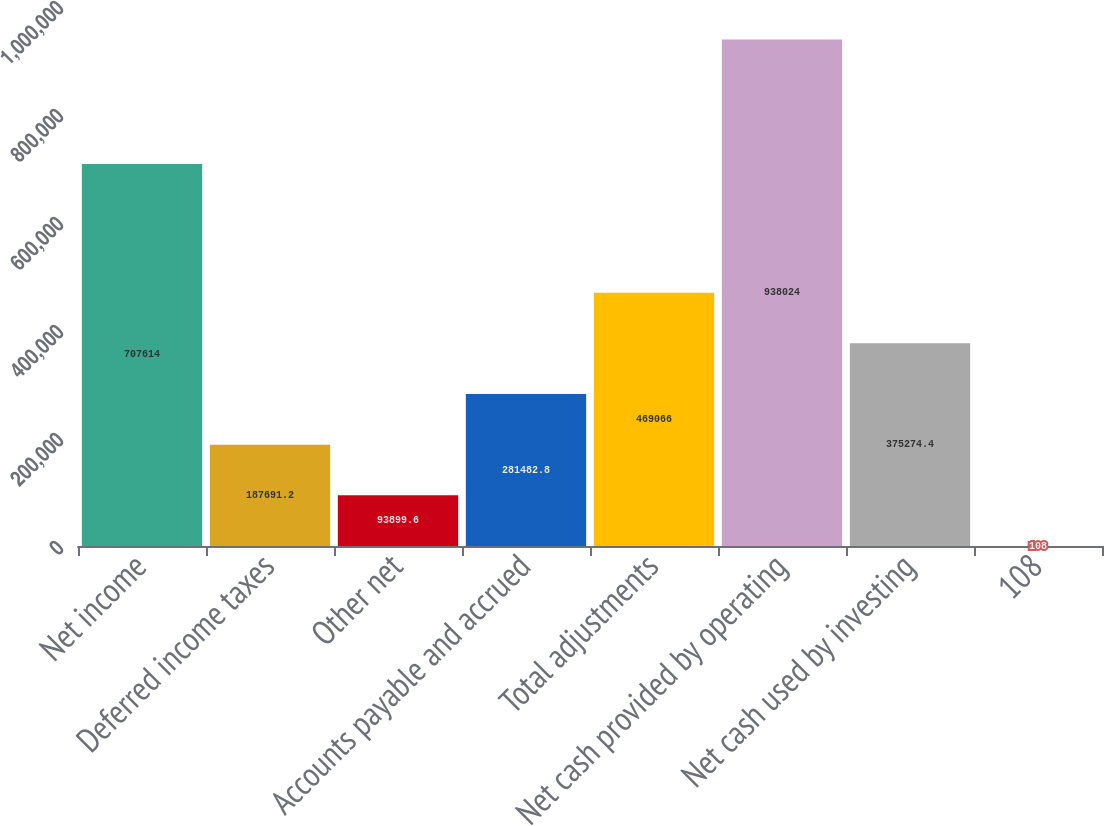<chart> <loc_0><loc_0><loc_500><loc_500><bar_chart><fcel>Net income<fcel>Deferred income taxes<fcel>Other net<fcel>Accounts payable and accrued<fcel>Total adjustments<fcel>Net cash provided by operating<fcel>Net cash used by investing<fcel>108<nl><fcel>707614<fcel>187691<fcel>93899.6<fcel>281483<fcel>469066<fcel>938024<fcel>375274<fcel>108<nl></chart> 